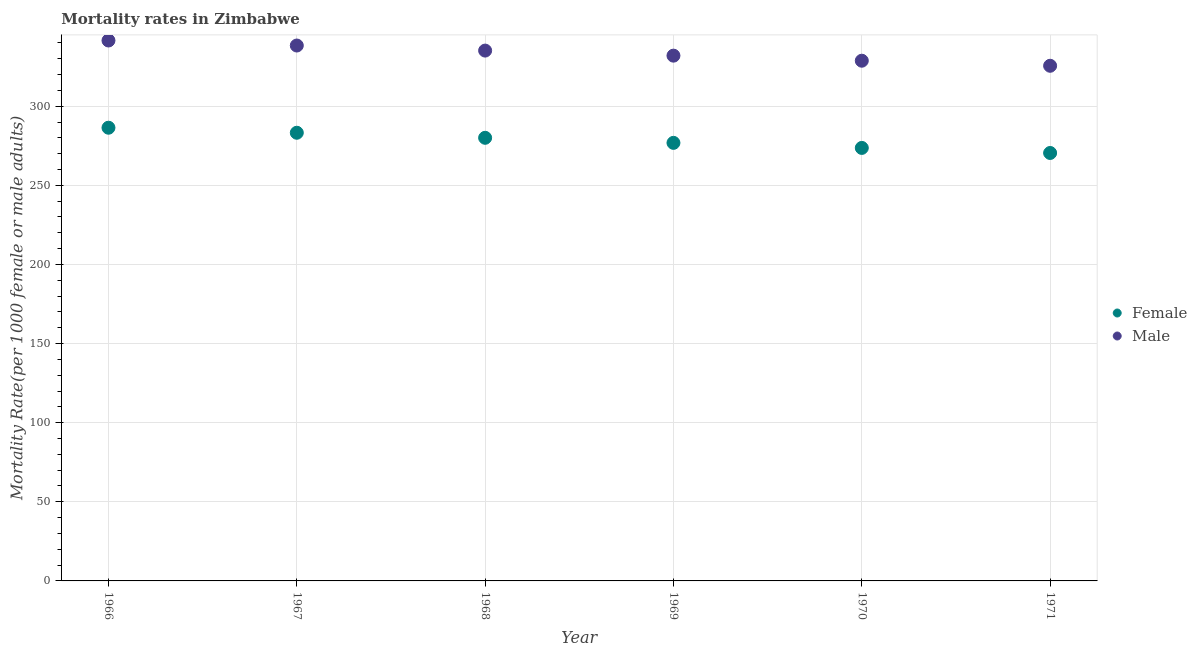Is the number of dotlines equal to the number of legend labels?
Give a very brief answer. Yes. What is the female mortality rate in 1970?
Give a very brief answer. 273.65. Across all years, what is the maximum male mortality rate?
Keep it short and to the point. 341.54. Across all years, what is the minimum female mortality rate?
Provide a short and direct response. 270.46. In which year was the male mortality rate maximum?
Make the answer very short. 1966. What is the total male mortality rate in the graph?
Your response must be concise. 2001.36. What is the difference between the female mortality rate in 1967 and that in 1971?
Provide a succinct answer. 12.78. What is the difference between the female mortality rate in 1966 and the male mortality rate in 1970?
Your response must be concise. -42.35. What is the average female mortality rate per year?
Your response must be concise. 278.44. In the year 1971, what is the difference between the male mortality rate and female mortality rate?
Provide a succinct answer. 55.11. What is the ratio of the female mortality rate in 1967 to that in 1969?
Your answer should be compact. 1.02. Is the male mortality rate in 1966 less than that in 1971?
Ensure brevity in your answer.  No. Is the difference between the female mortality rate in 1966 and 1970 greater than the difference between the male mortality rate in 1966 and 1970?
Your answer should be compact. No. What is the difference between the highest and the second highest female mortality rate?
Offer a terse response. 3.18. What is the difference between the highest and the lowest female mortality rate?
Give a very brief answer. 15.96. Is the sum of the male mortality rate in 1966 and 1971 greater than the maximum female mortality rate across all years?
Provide a succinct answer. Yes. Is the male mortality rate strictly greater than the female mortality rate over the years?
Your answer should be compact. Yes. Is the male mortality rate strictly less than the female mortality rate over the years?
Give a very brief answer. No. How many dotlines are there?
Make the answer very short. 2. Are the values on the major ticks of Y-axis written in scientific E-notation?
Provide a succinct answer. No. Does the graph contain grids?
Give a very brief answer. Yes. How are the legend labels stacked?
Provide a succinct answer. Vertical. What is the title of the graph?
Your answer should be very brief. Mortality rates in Zimbabwe. What is the label or title of the Y-axis?
Provide a succinct answer. Mortality Rate(per 1000 female or male adults). What is the Mortality Rate(per 1000 female or male adults) of Female in 1966?
Your answer should be compact. 286.42. What is the Mortality Rate(per 1000 female or male adults) in Male in 1966?
Give a very brief answer. 341.54. What is the Mortality Rate(per 1000 female or male adults) in Female in 1967?
Give a very brief answer. 283.24. What is the Mortality Rate(per 1000 female or male adults) of Male in 1967?
Provide a succinct answer. 338.36. What is the Mortality Rate(per 1000 female or male adults) of Female in 1968?
Offer a terse response. 280.04. What is the Mortality Rate(per 1000 female or male adults) in Male in 1968?
Provide a succinct answer. 335.16. What is the Mortality Rate(per 1000 female or male adults) in Female in 1969?
Offer a terse response. 276.85. What is the Mortality Rate(per 1000 female or male adults) of Male in 1969?
Your response must be concise. 331.96. What is the Mortality Rate(per 1000 female or male adults) of Female in 1970?
Provide a short and direct response. 273.65. What is the Mortality Rate(per 1000 female or male adults) in Male in 1970?
Provide a succinct answer. 328.76. What is the Mortality Rate(per 1000 female or male adults) in Female in 1971?
Offer a very short reply. 270.46. What is the Mortality Rate(per 1000 female or male adults) in Male in 1971?
Give a very brief answer. 325.56. Across all years, what is the maximum Mortality Rate(per 1000 female or male adults) of Female?
Your response must be concise. 286.42. Across all years, what is the maximum Mortality Rate(per 1000 female or male adults) in Male?
Ensure brevity in your answer.  341.54. Across all years, what is the minimum Mortality Rate(per 1000 female or male adults) in Female?
Keep it short and to the point. 270.46. Across all years, what is the minimum Mortality Rate(per 1000 female or male adults) in Male?
Make the answer very short. 325.56. What is the total Mortality Rate(per 1000 female or male adults) of Female in the graph?
Offer a very short reply. 1670.66. What is the total Mortality Rate(per 1000 female or male adults) of Male in the graph?
Provide a short and direct response. 2001.36. What is the difference between the Mortality Rate(per 1000 female or male adults) in Female in 1966 and that in 1967?
Make the answer very short. 3.18. What is the difference between the Mortality Rate(per 1000 female or male adults) of Male in 1966 and that in 1967?
Keep it short and to the point. 3.18. What is the difference between the Mortality Rate(per 1000 female or male adults) in Female in 1966 and that in 1968?
Give a very brief answer. 6.38. What is the difference between the Mortality Rate(per 1000 female or male adults) of Male in 1966 and that in 1968?
Your answer should be very brief. 6.38. What is the difference between the Mortality Rate(per 1000 female or male adults) in Female in 1966 and that in 1969?
Make the answer very short. 9.57. What is the difference between the Mortality Rate(per 1000 female or male adults) of Male in 1966 and that in 1969?
Provide a short and direct response. 9.58. What is the difference between the Mortality Rate(per 1000 female or male adults) of Female in 1966 and that in 1970?
Your answer should be very brief. 12.77. What is the difference between the Mortality Rate(per 1000 female or male adults) of Male in 1966 and that in 1970?
Your answer should be very brief. 12.78. What is the difference between the Mortality Rate(per 1000 female or male adults) of Female in 1966 and that in 1971?
Provide a short and direct response. 15.96. What is the difference between the Mortality Rate(per 1000 female or male adults) of Male in 1966 and that in 1971?
Your answer should be very brief. 15.98. What is the difference between the Mortality Rate(per 1000 female or male adults) in Female in 1967 and that in 1968?
Offer a terse response. 3.2. What is the difference between the Mortality Rate(per 1000 female or male adults) in Male in 1967 and that in 1968?
Your response must be concise. 3.2. What is the difference between the Mortality Rate(per 1000 female or male adults) of Female in 1967 and that in 1969?
Your answer should be compact. 6.39. What is the difference between the Mortality Rate(per 1000 female or male adults) in Male in 1967 and that in 1969?
Your answer should be compact. 6.4. What is the difference between the Mortality Rate(per 1000 female or male adults) of Female in 1967 and that in 1970?
Offer a very short reply. 9.59. What is the difference between the Mortality Rate(per 1000 female or male adults) in Male in 1967 and that in 1970?
Provide a succinct answer. 9.6. What is the difference between the Mortality Rate(per 1000 female or male adults) in Female in 1967 and that in 1971?
Your response must be concise. 12.78. What is the difference between the Mortality Rate(per 1000 female or male adults) in Male in 1967 and that in 1971?
Give a very brief answer. 12.8. What is the difference between the Mortality Rate(per 1000 female or male adults) of Female in 1968 and that in 1969?
Make the answer very short. 3.19. What is the difference between the Mortality Rate(per 1000 female or male adults) of Male in 1968 and that in 1969?
Your response must be concise. 3.2. What is the difference between the Mortality Rate(per 1000 female or male adults) in Female in 1968 and that in 1970?
Offer a very short reply. 6.39. What is the difference between the Mortality Rate(per 1000 female or male adults) in Male in 1968 and that in 1970?
Ensure brevity in your answer.  6.4. What is the difference between the Mortality Rate(per 1000 female or male adults) of Female in 1968 and that in 1971?
Your answer should be very brief. 9.59. What is the difference between the Mortality Rate(per 1000 female or male adults) of Male in 1968 and that in 1971?
Provide a short and direct response. 9.6. What is the difference between the Mortality Rate(per 1000 female or male adults) of Female in 1969 and that in 1970?
Give a very brief answer. 3.19. What is the difference between the Mortality Rate(per 1000 female or male adults) of Male in 1969 and that in 1970?
Offer a very short reply. 3.2. What is the difference between the Mortality Rate(per 1000 female or male adults) of Female in 1969 and that in 1971?
Provide a succinct answer. 6.39. What is the difference between the Mortality Rate(per 1000 female or male adults) in Male in 1969 and that in 1971?
Offer a terse response. 6.4. What is the difference between the Mortality Rate(per 1000 female or male adults) of Female in 1970 and that in 1971?
Make the answer very short. 3.19. What is the difference between the Mortality Rate(per 1000 female or male adults) of Male in 1970 and that in 1971?
Offer a very short reply. 3.2. What is the difference between the Mortality Rate(per 1000 female or male adults) of Female in 1966 and the Mortality Rate(per 1000 female or male adults) of Male in 1967?
Make the answer very short. -51.94. What is the difference between the Mortality Rate(per 1000 female or male adults) in Female in 1966 and the Mortality Rate(per 1000 female or male adults) in Male in 1968?
Offer a terse response. -48.74. What is the difference between the Mortality Rate(per 1000 female or male adults) of Female in 1966 and the Mortality Rate(per 1000 female or male adults) of Male in 1969?
Your response must be concise. -45.55. What is the difference between the Mortality Rate(per 1000 female or male adults) in Female in 1966 and the Mortality Rate(per 1000 female or male adults) in Male in 1970?
Offer a terse response. -42.35. What is the difference between the Mortality Rate(per 1000 female or male adults) of Female in 1966 and the Mortality Rate(per 1000 female or male adults) of Male in 1971?
Provide a succinct answer. -39.15. What is the difference between the Mortality Rate(per 1000 female or male adults) in Female in 1967 and the Mortality Rate(per 1000 female or male adults) in Male in 1968?
Keep it short and to the point. -51.92. What is the difference between the Mortality Rate(per 1000 female or male adults) in Female in 1967 and the Mortality Rate(per 1000 female or male adults) in Male in 1969?
Your answer should be compact. -48.72. What is the difference between the Mortality Rate(per 1000 female or male adults) of Female in 1967 and the Mortality Rate(per 1000 female or male adults) of Male in 1970?
Make the answer very short. -45.52. What is the difference between the Mortality Rate(per 1000 female or male adults) in Female in 1967 and the Mortality Rate(per 1000 female or male adults) in Male in 1971?
Your answer should be compact. -42.33. What is the difference between the Mortality Rate(per 1000 female or male adults) of Female in 1968 and the Mortality Rate(per 1000 female or male adults) of Male in 1969?
Offer a very short reply. -51.92. What is the difference between the Mortality Rate(per 1000 female or male adults) of Female in 1968 and the Mortality Rate(per 1000 female or male adults) of Male in 1970?
Your response must be concise. -48.72. What is the difference between the Mortality Rate(per 1000 female or male adults) of Female in 1968 and the Mortality Rate(per 1000 female or male adults) of Male in 1971?
Provide a succinct answer. -45.52. What is the difference between the Mortality Rate(per 1000 female or male adults) of Female in 1969 and the Mortality Rate(per 1000 female or male adults) of Male in 1970?
Your answer should be very brief. -51.92. What is the difference between the Mortality Rate(per 1000 female or male adults) of Female in 1969 and the Mortality Rate(per 1000 female or male adults) of Male in 1971?
Your answer should be very brief. -48.72. What is the difference between the Mortality Rate(per 1000 female or male adults) of Female in 1970 and the Mortality Rate(per 1000 female or male adults) of Male in 1971?
Offer a very short reply. -51.91. What is the average Mortality Rate(per 1000 female or male adults) of Female per year?
Ensure brevity in your answer.  278.44. What is the average Mortality Rate(per 1000 female or male adults) of Male per year?
Give a very brief answer. 333.56. In the year 1966, what is the difference between the Mortality Rate(per 1000 female or male adults) in Female and Mortality Rate(per 1000 female or male adults) in Male?
Your answer should be compact. -55.12. In the year 1967, what is the difference between the Mortality Rate(per 1000 female or male adults) in Female and Mortality Rate(per 1000 female or male adults) in Male?
Offer a very short reply. -55.12. In the year 1968, what is the difference between the Mortality Rate(per 1000 female or male adults) of Female and Mortality Rate(per 1000 female or male adults) of Male?
Provide a short and direct response. -55.12. In the year 1969, what is the difference between the Mortality Rate(per 1000 female or male adults) in Female and Mortality Rate(per 1000 female or male adults) in Male?
Offer a terse response. -55.12. In the year 1970, what is the difference between the Mortality Rate(per 1000 female or male adults) of Female and Mortality Rate(per 1000 female or male adults) of Male?
Your answer should be compact. -55.11. In the year 1971, what is the difference between the Mortality Rate(per 1000 female or male adults) of Female and Mortality Rate(per 1000 female or male adults) of Male?
Offer a very short reply. -55.11. What is the ratio of the Mortality Rate(per 1000 female or male adults) in Female in 1966 to that in 1967?
Ensure brevity in your answer.  1.01. What is the ratio of the Mortality Rate(per 1000 female or male adults) of Male in 1966 to that in 1967?
Provide a succinct answer. 1.01. What is the ratio of the Mortality Rate(per 1000 female or male adults) in Female in 1966 to that in 1968?
Your answer should be very brief. 1.02. What is the ratio of the Mortality Rate(per 1000 female or male adults) in Female in 1966 to that in 1969?
Provide a short and direct response. 1.03. What is the ratio of the Mortality Rate(per 1000 female or male adults) in Male in 1966 to that in 1969?
Your answer should be very brief. 1.03. What is the ratio of the Mortality Rate(per 1000 female or male adults) of Female in 1966 to that in 1970?
Make the answer very short. 1.05. What is the ratio of the Mortality Rate(per 1000 female or male adults) in Male in 1966 to that in 1970?
Keep it short and to the point. 1.04. What is the ratio of the Mortality Rate(per 1000 female or male adults) of Female in 1966 to that in 1971?
Offer a terse response. 1.06. What is the ratio of the Mortality Rate(per 1000 female or male adults) of Male in 1966 to that in 1971?
Your response must be concise. 1.05. What is the ratio of the Mortality Rate(per 1000 female or male adults) of Female in 1967 to that in 1968?
Offer a terse response. 1.01. What is the ratio of the Mortality Rate(per 1000 female or male adults) of Male in 1967 to that in 1968?
Keep it short and to the point. 1.01. What is the ratio of the Mortality Rate(per 1000 female or male adults) of Female in 1967 to that in 1969?
Your answer should be very brief. 1.02. What is the ratio of the Mortality Rate(per 1000 female or male adults) of Male in 1967 to that in 1969?
Ensure brevity in your answer.  1.02. What is the ratio of the Mortality Rate(per 1000 female or male adults) in Female in 1967 to that in 1970?
Give a very brief answer. 1.03. What is the ratio of the Mortality Rate(per 1000 female or male adults) of Male in 1967 to that in 1970?
Offer a very short reply. 1.03. What is the ratio of the Mortality Rate(per 1000 female or male adults) in Female in 1967 to that in 1971?
Keep it short and to the point. 1.05. What is the ratio of the Mortality Rate(per 1000 female or male adults) in Male in 1967 to that in 1971?
Your response must be concise. 1.04. What is the ratio of the Mortality Rate(per 1000 female or male adults) of Female in 1968 to that in 1969?
Give a very brief answer. 1.01. What is the ratio of the Mortality Rate(per 1000 female or male adults) of Male in 1968 to that in 1969?
Ensure brevity in your answer.  1.01. What is the ratio of the Mortality Rate(per 1000 female or male adults) in Female in 1968 to that in 1970?
Provide a short and direct response. 1.02. What is the ratio of the Mortality Rate(per 1000 female or male adults) in Male in 1968 to that in 1970?
Your answer should be compact. 1.02. What is the ratio of the Mortality Rate(per 1000 female or male adults) in Female in 1968 to that in 1971?
Your response must be concise. 1.04. What is the ratio of the Mortality Rate(per 1000 female or male adults) of Male in 1968 to that in 1971?
Keep it short and to the point. 1.03. What is the ratio of the Mortality Rate(per 1000 female or male adults) of Female in 1969 to that in 1970?
Your answer should be very brief. 1.01. What is the ratio of the Mortality Rate(per 1000 female or male adults) in Male in 1969 to that in 1970?
Provide a short and direct response. 1.01. What is the ratio of the Mortality Rate(per 1000 female or male adults) in Female in 1969 to that in 1971?
Provide a succinct answer. 1.02. What is the ratio of the Mortality Rate(per 1000 female or male adults) in Male in 1969 to that in 1971?
Your answer should be compact. 1.02. What is the ratio of the Mortality Rate(per 1000 female or male adults) of Female in 1970 to that in 1971?
Your answer should be very brief. 1.01. What is the ratio of the Mortality Rate(per 1000 female or male adults) in Male in 1970 to that in 1971?
Your response must be concise. 1.01. What is the difference between the highest and the second highest Mortality Rate(per 1000 female or male adults) of Female?
Provide a succinct answer. 3.18. What is the difference between the highest and the second highest Mortality Rate(per 1000 female or male adults) of Male?
Ensure brevity in your answer.  3.18. What is the difference between the highest and the lowest Mortality Rate(per 1000 female or male adults) in Female?
Offer a very short reply. 15.96. What is the difference between the highest and the lowest Mortality Rate(per 1000 female or male adults) in Male?
Ensure brevity in your answer.  15.98. 